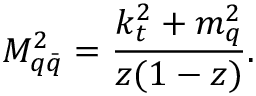Convert formula to latex. <formula><loc_0><loc_0><loc_500><loc_500>M _ { q { \bar { q } } } ^ { 2 } = \frac { k _ { t } ^ { 2 } + m _ { q } ^ { 2 } } { z ( 1 - z ) } .</formula> 